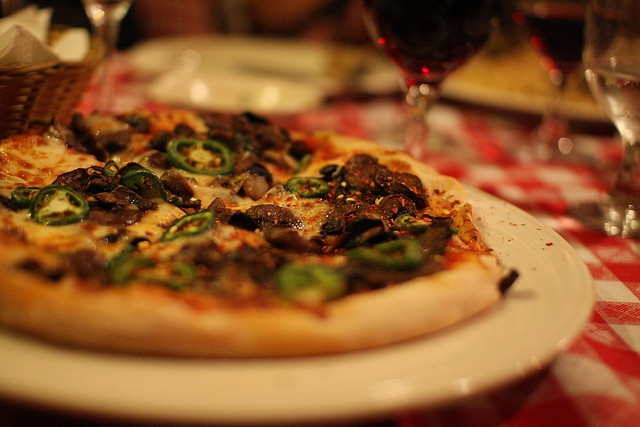Describe the objects in this image and their specific colors. I can see pizza in black, brown, maroon, and orange tones, dining table in black, brown, maroon, and tan tones, wine glass in black, maroon, brown, and red tones, wine glass in black, maroon, and brown tones, and wine glass in black, maroon, and brown tones in this image. 